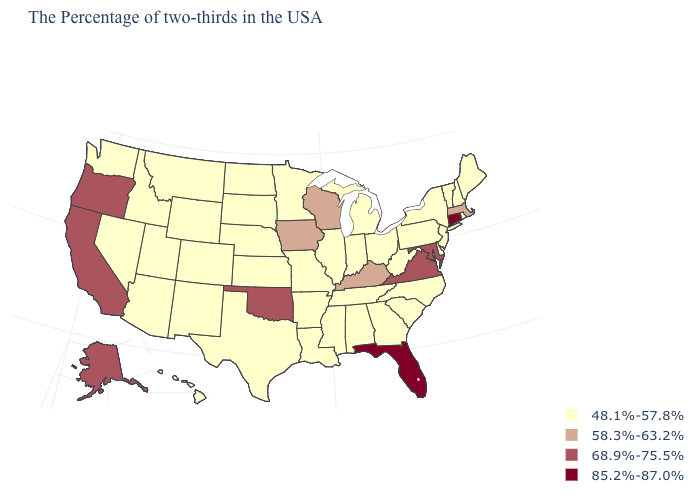Among the states that border Delaware , does Maryland have the highest value?
Keep it brief. Yes. What is the value of New Jersey?
Write a very short answer. 48.1%-57.8%. Does Indiana have a lower value than West Virginia?
Short answer required. No. Name the states that have a value in the range 68.9%-75.5%?
Give a very brief answer. Maryland, Virginia, Oklahoma, California, Oregon, Alaska. Which states have the lowest value in the USA?
Write a very short answer. Maine, Rhode Island, New Hampshire, Vermont, New York, New Jersey, Delaware, Pennsylvania, North Carolina, South Carolina, West Virginia, Ohio, Georgia, Michigan, Indiana, Alabama, Tennessee, Illinois, Mississippi, Louisiana, Missouri, Arkansas, Minnesota, Kansas, Nebraska, Texas, South Dakota, North Dakota, Wyoming, Colorado, New Mexico, Utah, Montana, Arizona, Idaho, Nevada, Washington, Hawaii. Name the states that have a value in the range 68.9%-75.5%?
Give a very brief answer. Maryland, Virginia, Oklahoma, California, Oregon, Alaska. Does the first symbol in the legend represent the smallest category?
Quick response, please. Yes. Name the states that have a value in the range 85.2%-87.0%?
Concise answer only. Connecticut, Florida. What is the value of Rhode Island?
Give a very brief answer. 48.1%-57.8%. What is the value of Delaware?
Write a very short answer. 48.1%-57.8%. Does Connecticut have the lowest value in the Northeast?
Give a very brief answer. No. Among the states that border Washington , which have the highest value?
Quick response, please. Oregon. Does Connecticut have the lowest value in the USA?
Quick response, please. No. What is the value of North Dakota?
Write a very short answer. 48.1%-57.8%. Which states have the lowest value in the South?
Short answer required. Delaware, North Carolina, South Carolina, West Virginia, Georgia, Alabama, Tennessee, Mississippi, Louisiana, Arkansas, Texas. 